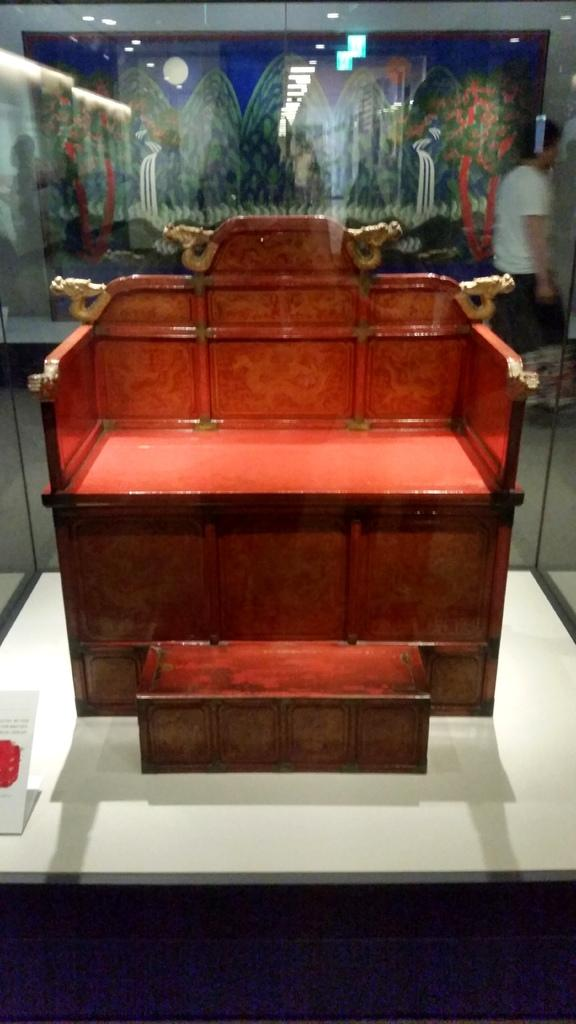What is the color of the chair-like object inside the glass? The chair-like object is red. What is the color of the surface the object is on? The object is on a white surface. What can be seen happening in the background of the image? There is a man walking in the background. What is present on the wall in the background? There is a frame on the wall in the background. What type of car does the father drive in the image? There is no car or father present in the image. 